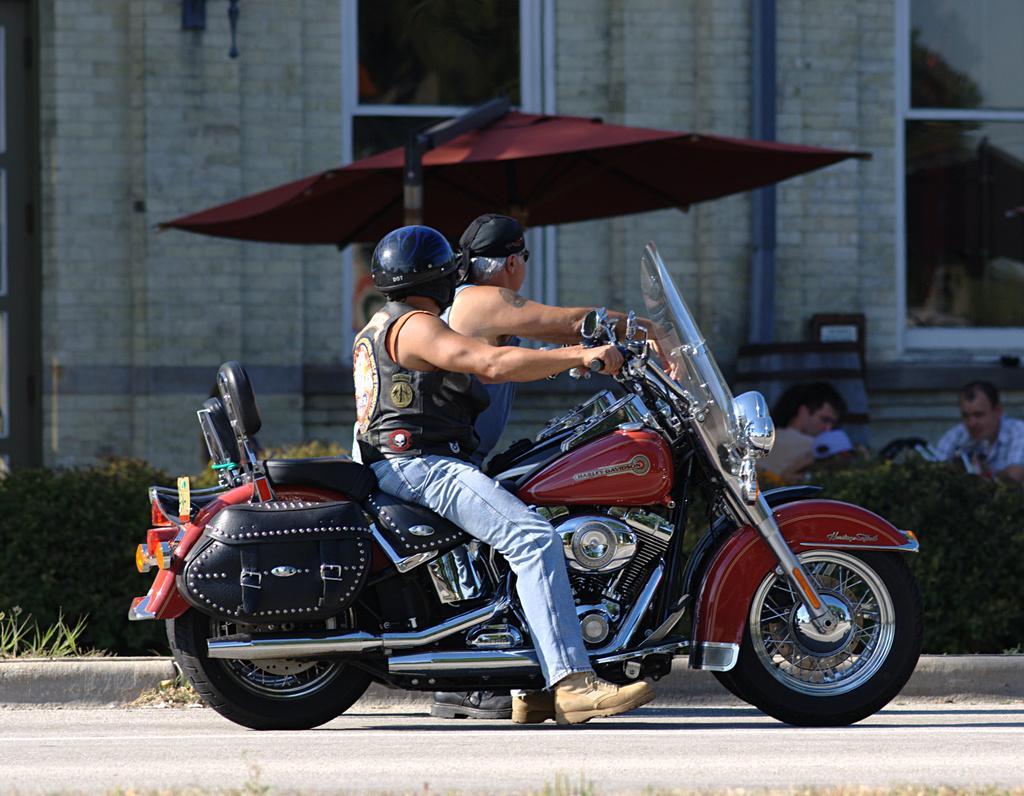Could you give a brief overview of what you see in this image? In the center we can see two persons were sitting on the bike. On the back we can see umbrella,wall and two more persons were sitting and plant. 